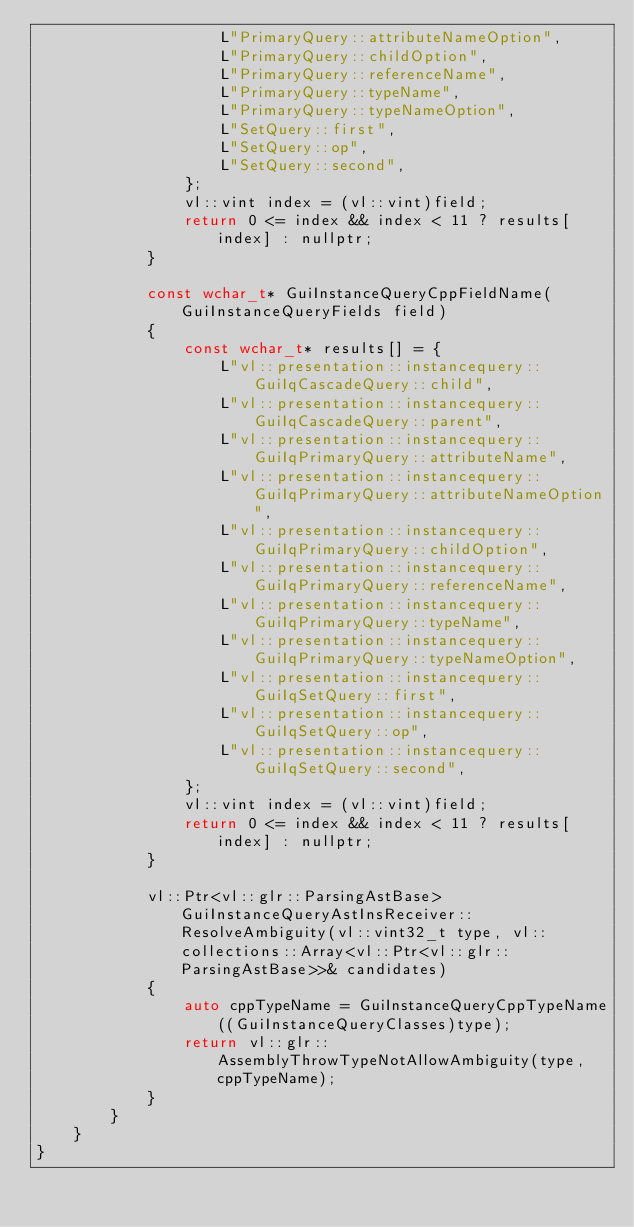<code> <loc_0><loc_0><loc_500><loc_500><_C++_>					L"PrimaryQuery::attributeNameOption",
					L"PrimaryQuery::childOption",
					L"PrimaryQuery::referenceName",
					L"PrimaryQuery::typeName",
					L"PrimaryQuery::typeNameOption",
					L"SetQuery::first",
					L"SetQuery::op",
					L"SetQuery::second",
				};
				vl::vint index = (vl::vint)field;
				return 0 <= index && index < 11 ? results[index] : nullptr;
			}

			const wchar_t* GuiInstanceQueryCppFieldName(GuiInstanceQueryFields field)
			{
				const wchar_t* results[] = {
					L"vl::presentation::instancequery::GuiIqCascadeQuery::child",
					L"vl::presentation::instancequery::GuiIqCascadeQuery::parent",
					L"vl::presentation::instancequery::GuiIqPrimaryQuery::attributeName",
					L"vl::presentation::instancequery::GuiIqPrimaryQuery::attributeNameOption",
					L"vl::presentation::instancequery::GuiIqPrimaryQuery::childOption",
					L"vl::presentation::instancequery::GuiIqPrimaryQuery::referenceName",
					L"vl::presentation::instancequery::GuiIqPrimaryQuery::typeName",
					L"vl::presentation::instancequery::GuiIqPrimaryQuery::typeNameOption",
					L"vl::presentation::instancequery::GuiIqSetQuery::first",
					L"vl::presentation::instancequery::GuiIqSetQuery::op",
					L"vl::presentation::instancequery::GuiIqSetQuery::second",
				};
				vl::vint index = (vl::vint)field;
				return 0 <= index && index < 11 ? results[index] : nullptr;
			}

			vl::Ptr<vl::glr::ParsingAstBase> GuiInstanceQueryAstInsReceiver::ResolveAmbiguity(vl::vint32_t type, vl::collections::Array<vl::Ptr<vl::glr::ParsingAstBase>>& candidates)
			{
				auto cppTypeName = GuiInstanceQueryCppTypeName((GuiInstanceQueryClasses)type);
				return vl::glr::AssemblyThrowTypeNotAllowAmbiguity(type, cppTypeName);
			}
		}
	}
}
</code> 